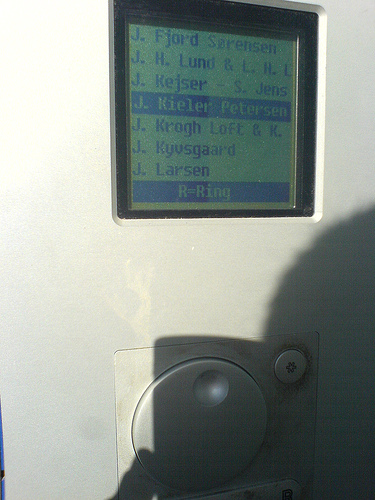<image>
Is there a screen in the panel? Yes. The screen is contained within or inside the panel, showing a containment relationship. 